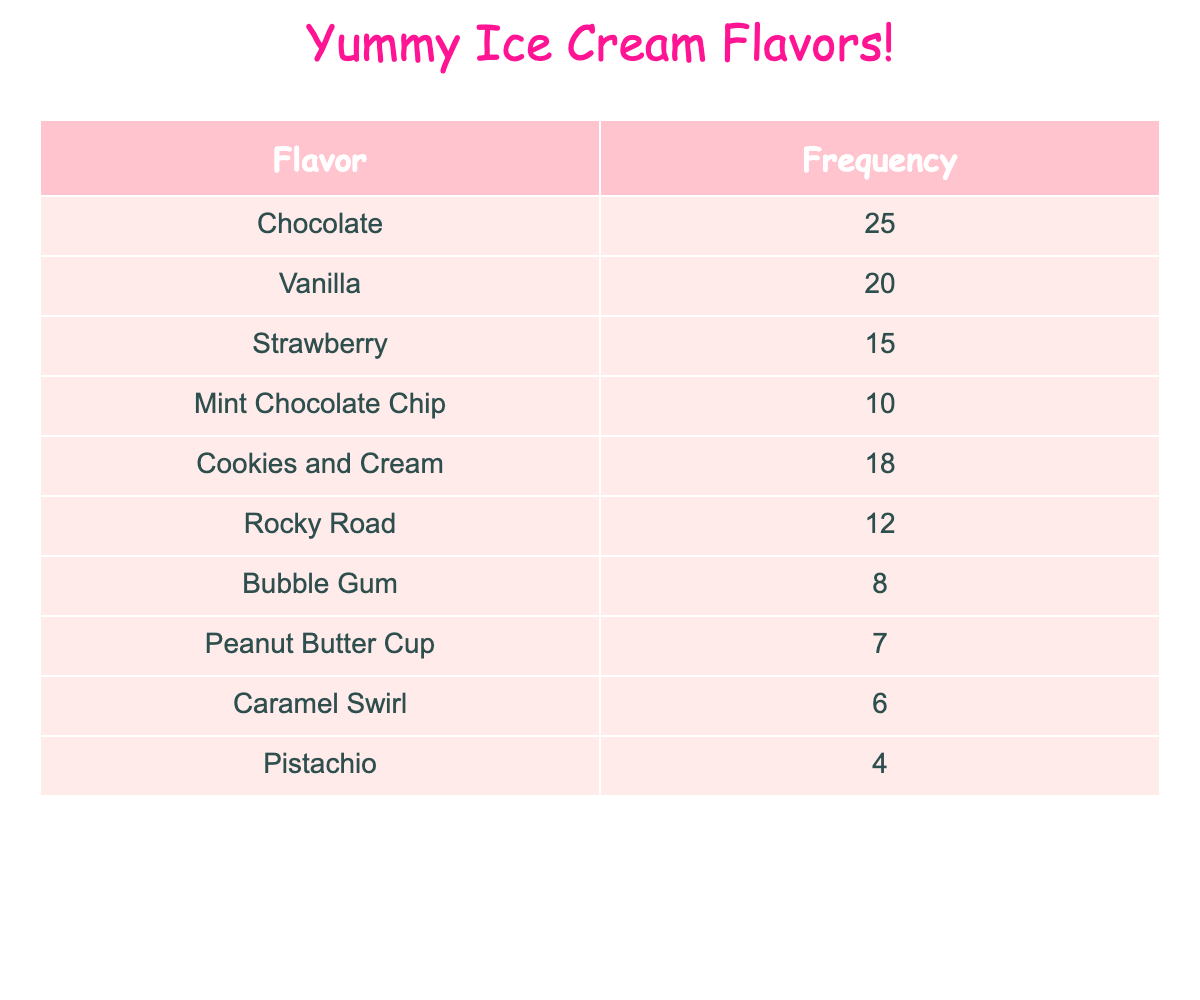What is the flavor with the highest frequency? Looking at the frequency of each flavor, Chocolate has the highest frequency of 25.
Answer: Chocolate How many kids chose Vanilla? The table shows that 20 kids chose Vanilla.
Answer: 20 Which flavor has a lower frequency: Rocky Road or Peanut Butter Cup? Rocky Road has a frequency of 12, while Peanut Butter Cup has a lower frequency of 7. Therefore, Peanut Butter Cup has a lower frequency.
Answer: Peanut Butter Cup What is the total frequency of all ice cream flavors? To find the total frequency, we add all the frequencies together: 25 + 20 + 15 + 10 + 18 + 12 + 8 + 7 + 6 + 4 = 125.
Answer: 125 Are there more kids who like Mint Chocolate Chip than those who like Caramel Swirl? Mint Chocolate Chip has a frequency of 10, while Caramel Swirl has a frequency of 6. Since 10 is greater than 6, more kids prefer Mint Chocolate Chip.
Answer: Yes What is the average frequency of the ice cream flavors? To find the average frequency, we first calculate the total frequency which is 125. Then, since there are 10 flavors, we divide 125 by 10, giving us an average of 12.5.
Answer: 12.5 Which flavor(s) have a frequency greater than 15? Filtering the table, Chocolate (25), Vanilla (20), and Cookies and Cream (18) all have frequencies greater than 15.
Answer: Chocolate, Vanilla, Cookies and Cream If we combine the frequencies of Bubble Gum and Peanut Butter Cup, do they exceed the frequency of Rocky Road? Bubble Gum has a frequency of 8, and Peanut Butter Cup has 7. Combined, they have a frequency of 15 (8 + 7). Rocky Road has a frequency of 12, and since 15 is greater than 12, the combined frequency exceeds that of Rocky Road.
Answer: Yes 